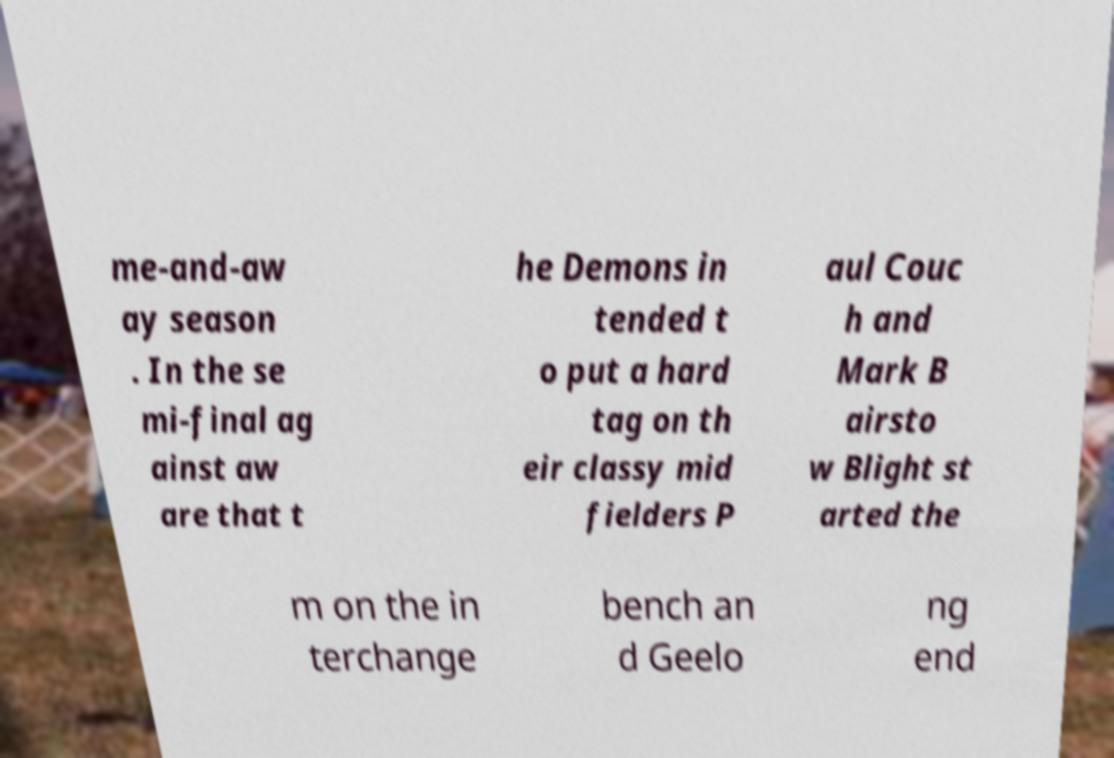Can you accurately transcribe the text from the provided image for me? me-and-aw ay season . In the se mi-final ag ainst aw are that t he Demons in tended t o put a hard tag on th eir classy mid fielders P aul Couc h and Mark B airsto w Blight st arted the m on the in terchange bench an d Geelo ng end 